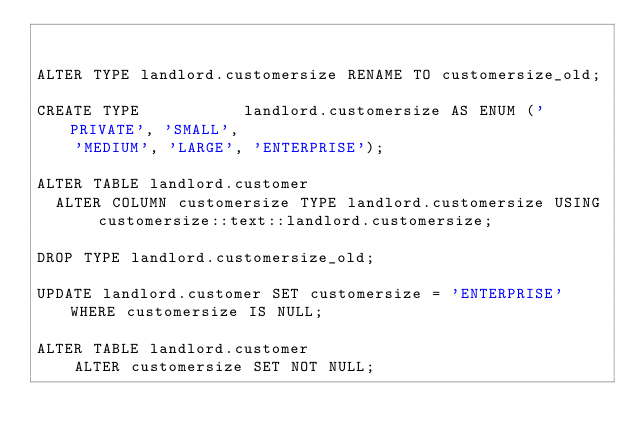<code> <loc_0><loc_0><loc_500><loc_500><_SQL_>
    
ALTER TYPE landlord.customersize RENAME TO customersize_old;

CREATE TYPE           landlord.customersize AS ENUM ('PRIVATE', 'SMALL',
    'MEDIUM', 'LARGE', 'ENTERPRISE');

ALTER TABLE landlord.customer
  ALTER COLUMN customersize TYPE landlord.customersize USING customersize::text::landlord.customersize;
  
DROP TYPE landlord.customersize_old;
    
UPDATE landlord.customer SET customersize = 'ENTERPRISE' WHERE customersize IS NULL;
    
ALTER TABLE landlord.customer
    ALTER customersize SET NOT NULL;</code> 